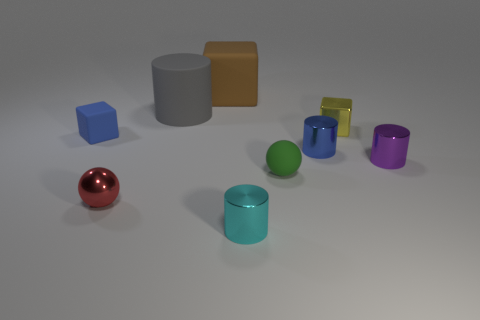Subtract all blue metallic cylinders. How many cylinders are left? 3 Subtract 2 cylinders. How many cylinders are left? 2 Add 1 large matte cylinders. How many objects exist? 10 Subtract all purple cylinders. How many cylinders are left? 3 Subtract all purple cylinders. Subtract all blue spheres. How many cylinders are left? 3 Subtract all balls. How many objects are left? 7 Add 3 purple matte cylinders. How many purple matte cylinders exist? 3 Subtract 0 gray cubes. How many objects are left? 9 Subtract all matte cylinders. Subtract all yellow things. How many objects are left? 7 Add 2 large brown things. How many large brown things are left? 3 